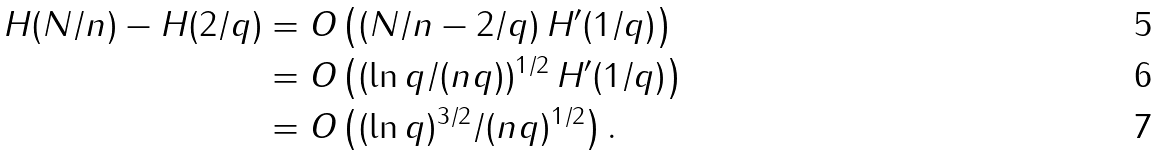<formula> <loc_0><loc_0><loc_500><loc_500>H ( N / n ) - H ( 2 / q ) & = O \left ( ( N / n - 2 / q ) \, H ^ { \prime } ( 1 / q ) \right ) \\ & = O \left ( ( \ln q / ( n q ) ) ^ { 1 / 2 } \, H ^ { \prime } ( 1 / q ) \right ) \\ & = O \left ( ( \ln q ) ^ { 3 / 2 } / ( n q ) ^ { 1 / 2 } \right ) .</formula> 